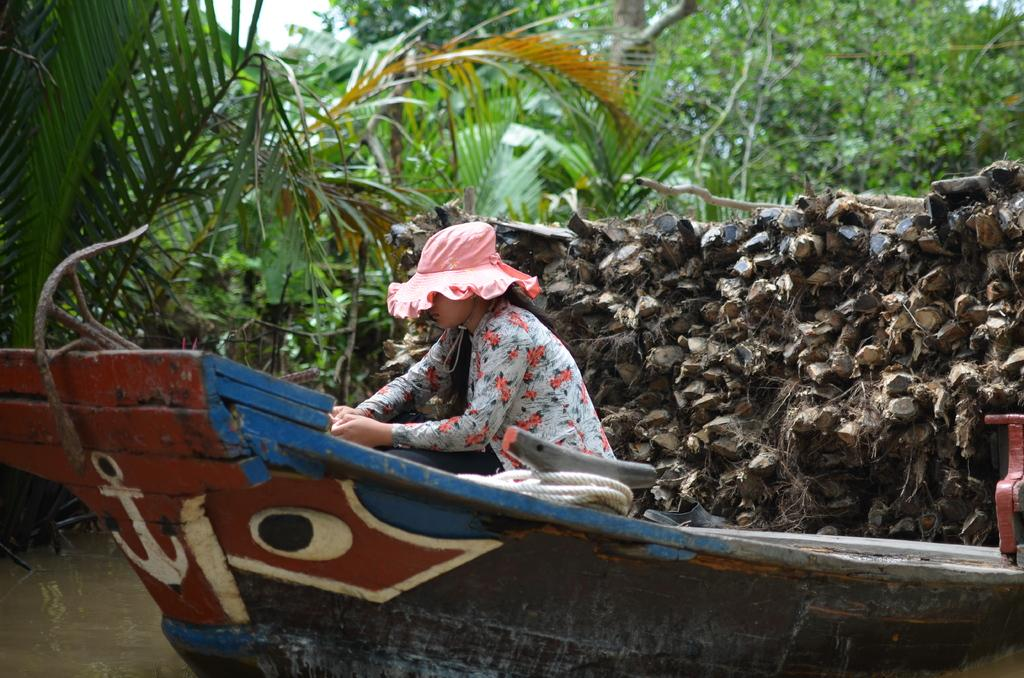Who is the main subject in the image? There is a girl in the image. What is the girl doing in the image? The girl is sitting on the water surface. What can be seen in the background of the image? There are trees and wooden objects visible in the background of the image. What type of hot drink is the girl holding in the image? There is no hot drink visible in the image; the girl is sitting on the water surface. 